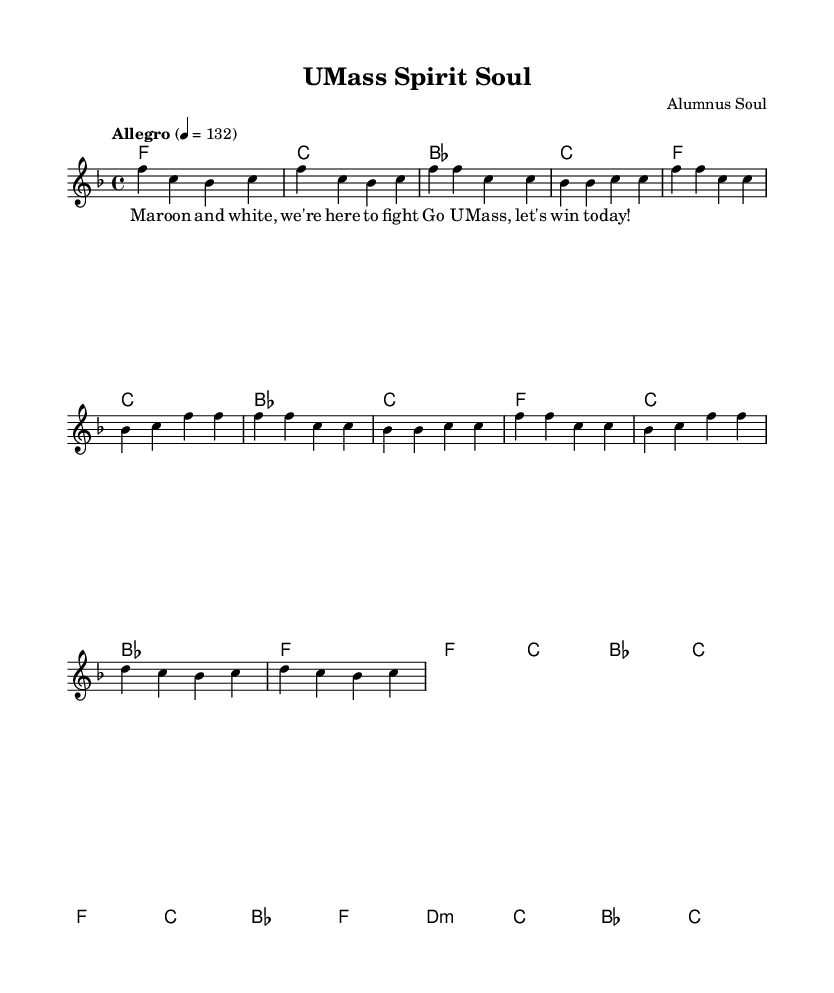What is the key signature of this music? The key signature is F major, which has one flat (B flat). This can be determined by looking at the key signature at the beginning of the staff, which indicates the notes that are flattened throughout the piece.
Answer: F major What is the time signature of this music? The time signature is 4/4, as indicated at the beginning of the score. This means there are four beats in each measure and the quarter note gets one beat.
Answer: 4/4 What is the tempo marking for this piece? The tempo marking is "Allegro" at a speed of quarter note equals 132 beats per minute. This information is noted above the staff and dictates the speed at which the piece should be played.
Answer: Allegro 4 = 132 How many measures are in the chorus section? The chorus section contains four measures, as can be seen in the section marked by the melody and harmonies, where two lines of melody span from the beginning to the end of the chorus.
Answer: 4 What chord does the bridge begin with? The bridge begins with a D minor chord, as indicated in the harmonies section. This chord is represented as d1:m in the chord mode, showing it as the starting chord of that section.
Answer: D minor What words are sung during the chorus? The words sung during the chorus are "Go U Mass, let's win today!" These lyrics can be found beneath the melodic line in the lyric mode section, specifically aligned with the chorus melody.
Answer: Go U Mass, let's win today! What is the harmonic structure of the verse? The harmonic structure of the verse consists of F, C, B flat, and F chords, repeated in a specific pattern for two sets. By examining the chord mode under the verse section, we see these chords lined up sequentially.
Answer: F, C, B flat 